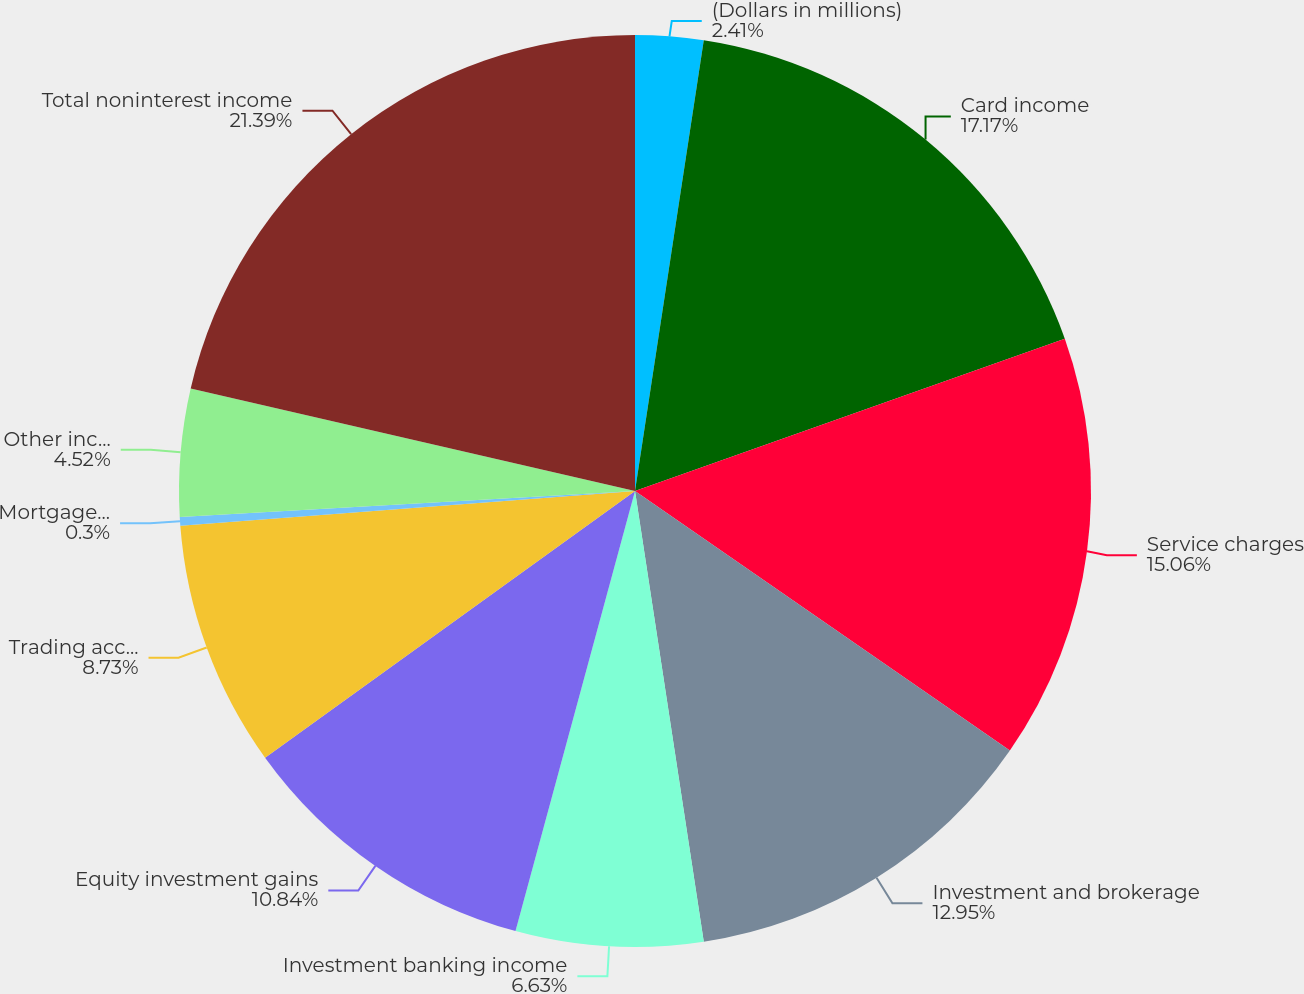<chart> <loc_0><loc_0><loc_500><loc_500><pie_chart><fcel>(Dollars in millions)<fcel>Card income<fcel>Service charges<fcel>Investment and brokerage<fcel>Investment banking income<fcel>Equity investment gains<fcel>Trading account profits<fcel>Mortgage banking income<fcel>Other income<fcel>Total noninterest income<nl><fcel>2.41%<fcel>17.17%<fcel>15.06%<fcel>12.95%<fcel>6.63%<fcel>10.84%<fcel>8.73%<fcel>0.3%<fcel>4.52%<fcel>21.39%<nl></chart> 